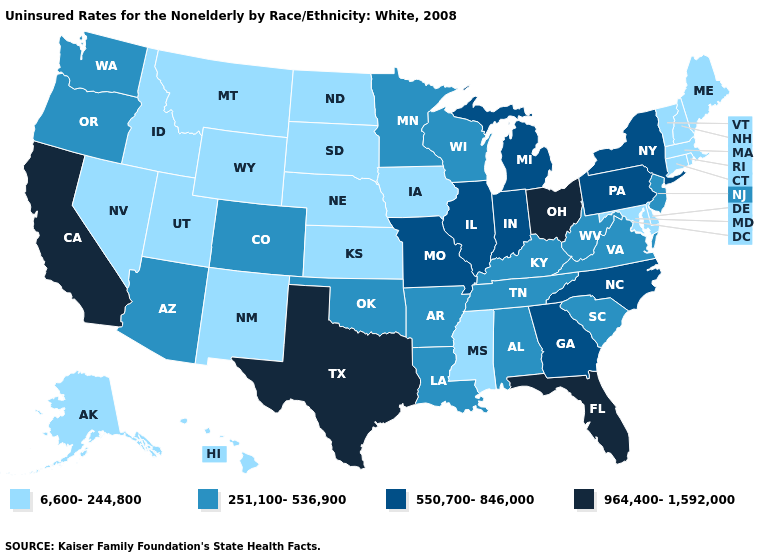Does Wyoming have the lowest value in the USA?
Give a very brief answer. Yes. Which states hav the highest value in the South?
Keep it brief. Florida, Texas. How many symbols are there in the legend?
Short answer required. 4. What is the value of New York?
Write a very short answer. 550,700-846,000. What is the value of Maine?
Write a very short answer. 6,600-244,800. What is the value of Nevada?
Give a very brief answer. 6,600-244,800. Does Delaware have the lowest value in the South?
Be succinct. Yes. How many symbols are there in the legend?
Keep it brief. 4. Name the states that have a value in the range 550,700-846,000?
Give a very brief answer. Georgia, Illinois, Indiana, Michigan, Missouri, New York, North Carolina, Pennsylvania. Name the states that have a value in the range 251,100-536,900?
Be succinct. Alabama, Arizona, Arkansas, Colorado, Kentucky, Louisiana, Minnesota, New Jersey, Oklahoma, Oregon, South Carolina, Tennessee, Virginia, Washington, West Virginia, Wisconsin. What is the value of North Dakota?
Keep it brief. 6,600-244,800. Which states hav the highest value in the MidWest?
Short answer required. Ohio. Does Illinois have the same value as Michigan?
Be succinct. Yes. What is the lowest value in states that border Louisiana?
Answer briefly. 6,600-244,800. Does Iowa have the lowest value in the MidWest?
Keep it brief. Yes. 